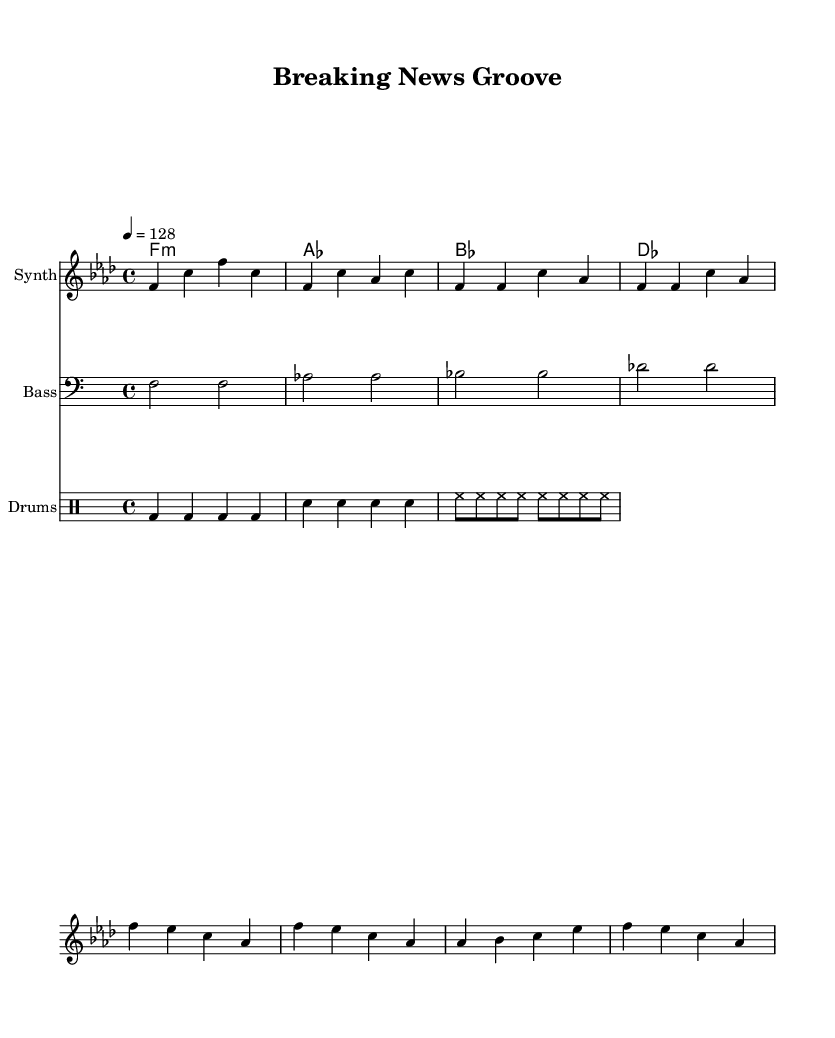What is the key signature of this music? The key signature is indicated by the presence of four flats in the key signature area, which corresponds to F minor.
Answer: F minor What is the time signature of this music? The time signature is shown at the beginning of the score and indicates a regular pattern; in this case, it is 4/4, meaning there are four beats in each measure.
Answer: 4/4 What is the tempo marking for this piece? The tempo marking is found next to the time signature and indicates the speed at which the piece should be played; here, it specifies a tempo of 128 beats per minute.
Answer: 128 How many measures are in the melody? The melody section consists of a total of eight measures, which can be counted by examining the bars in the staff where the notes are placed.
Answer: 8 What is the instrument indicated for the harmony part? The harmony section indicates that it is for chord names, which suggests it supports the overall piece without being tied to a specific instrumental sound like the melody and bass lines.
Answer: ChordNames What type of drum pattern is used in this piece? The drum pattern includes a combination of bass drums, snare drums, and hi-hat cymbals, all of which contribute to the typical rhythm found in house music, particularly the repetitive nature of the beats.
Answer: House rhythm What is the style of the remix in terms of music genre? The use of synths, a steady four-on-the-floor beat, and the incorporation of funky elements suggest this remix is firmly in the house music genre, characterized by a danceable tempo and groove.
Answer: Funky house 